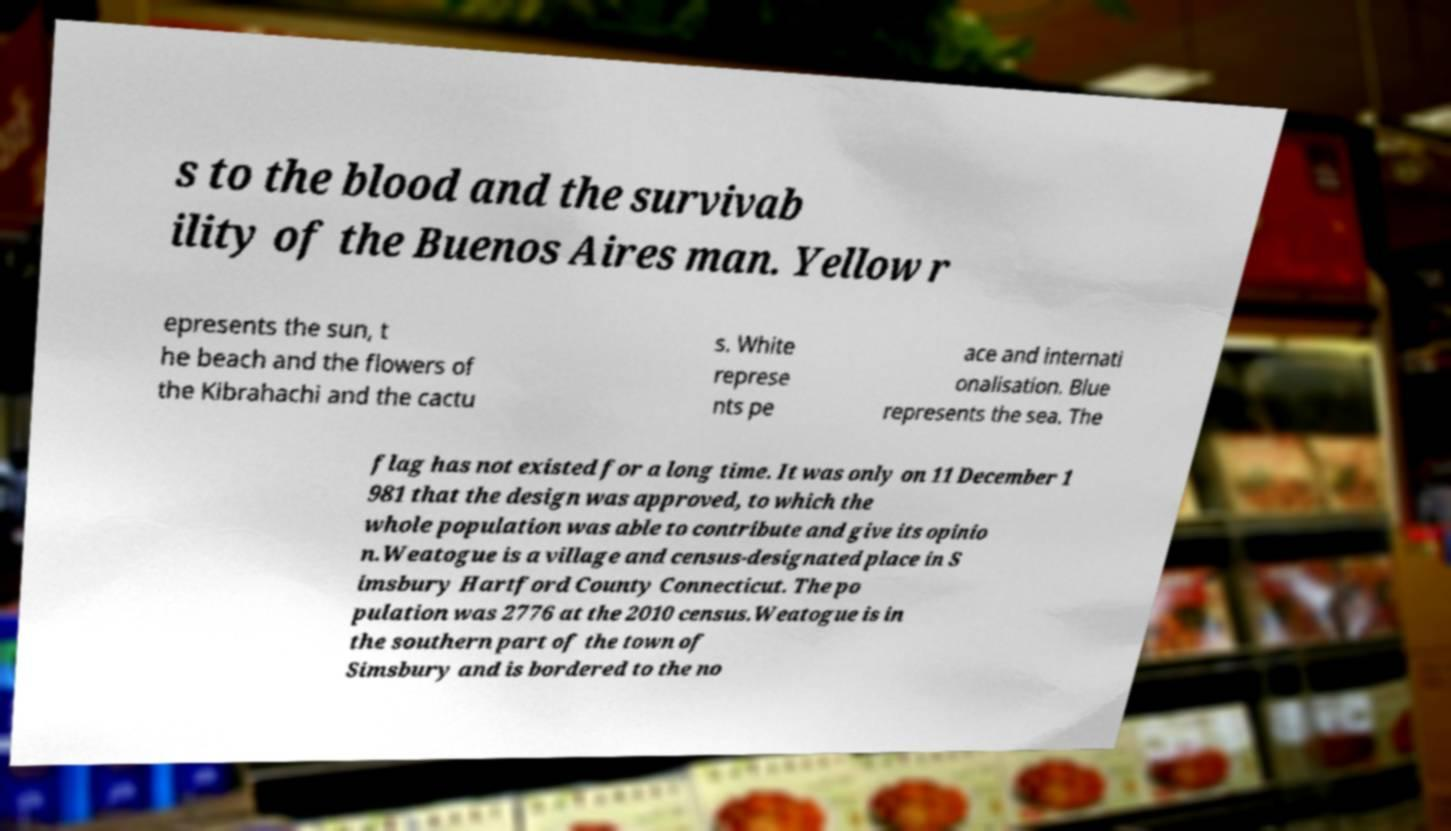What messages or text are displayed in this image? I need them in a readable, typed format. s to the blood and the survivab ility of the Buenos Aires man. Yellow r epresents the sun, t he beach and the flowers of the Kibrahachi and the cactu s. White represe nts pe ace and internati onalisation. Blue represents the sea. The flag has not existed for a long time. It was only on 11 December 1 981 that the design was approved, to which the whole population was able to contribute and give its opinio n.Weatogue is a village and census-designated place in S imsbury Hartford County Connecticut. The po pulation was 2776 at the 2010 census.Weatogue is in the southern part of the town of Simsbury and is bordered to the no 